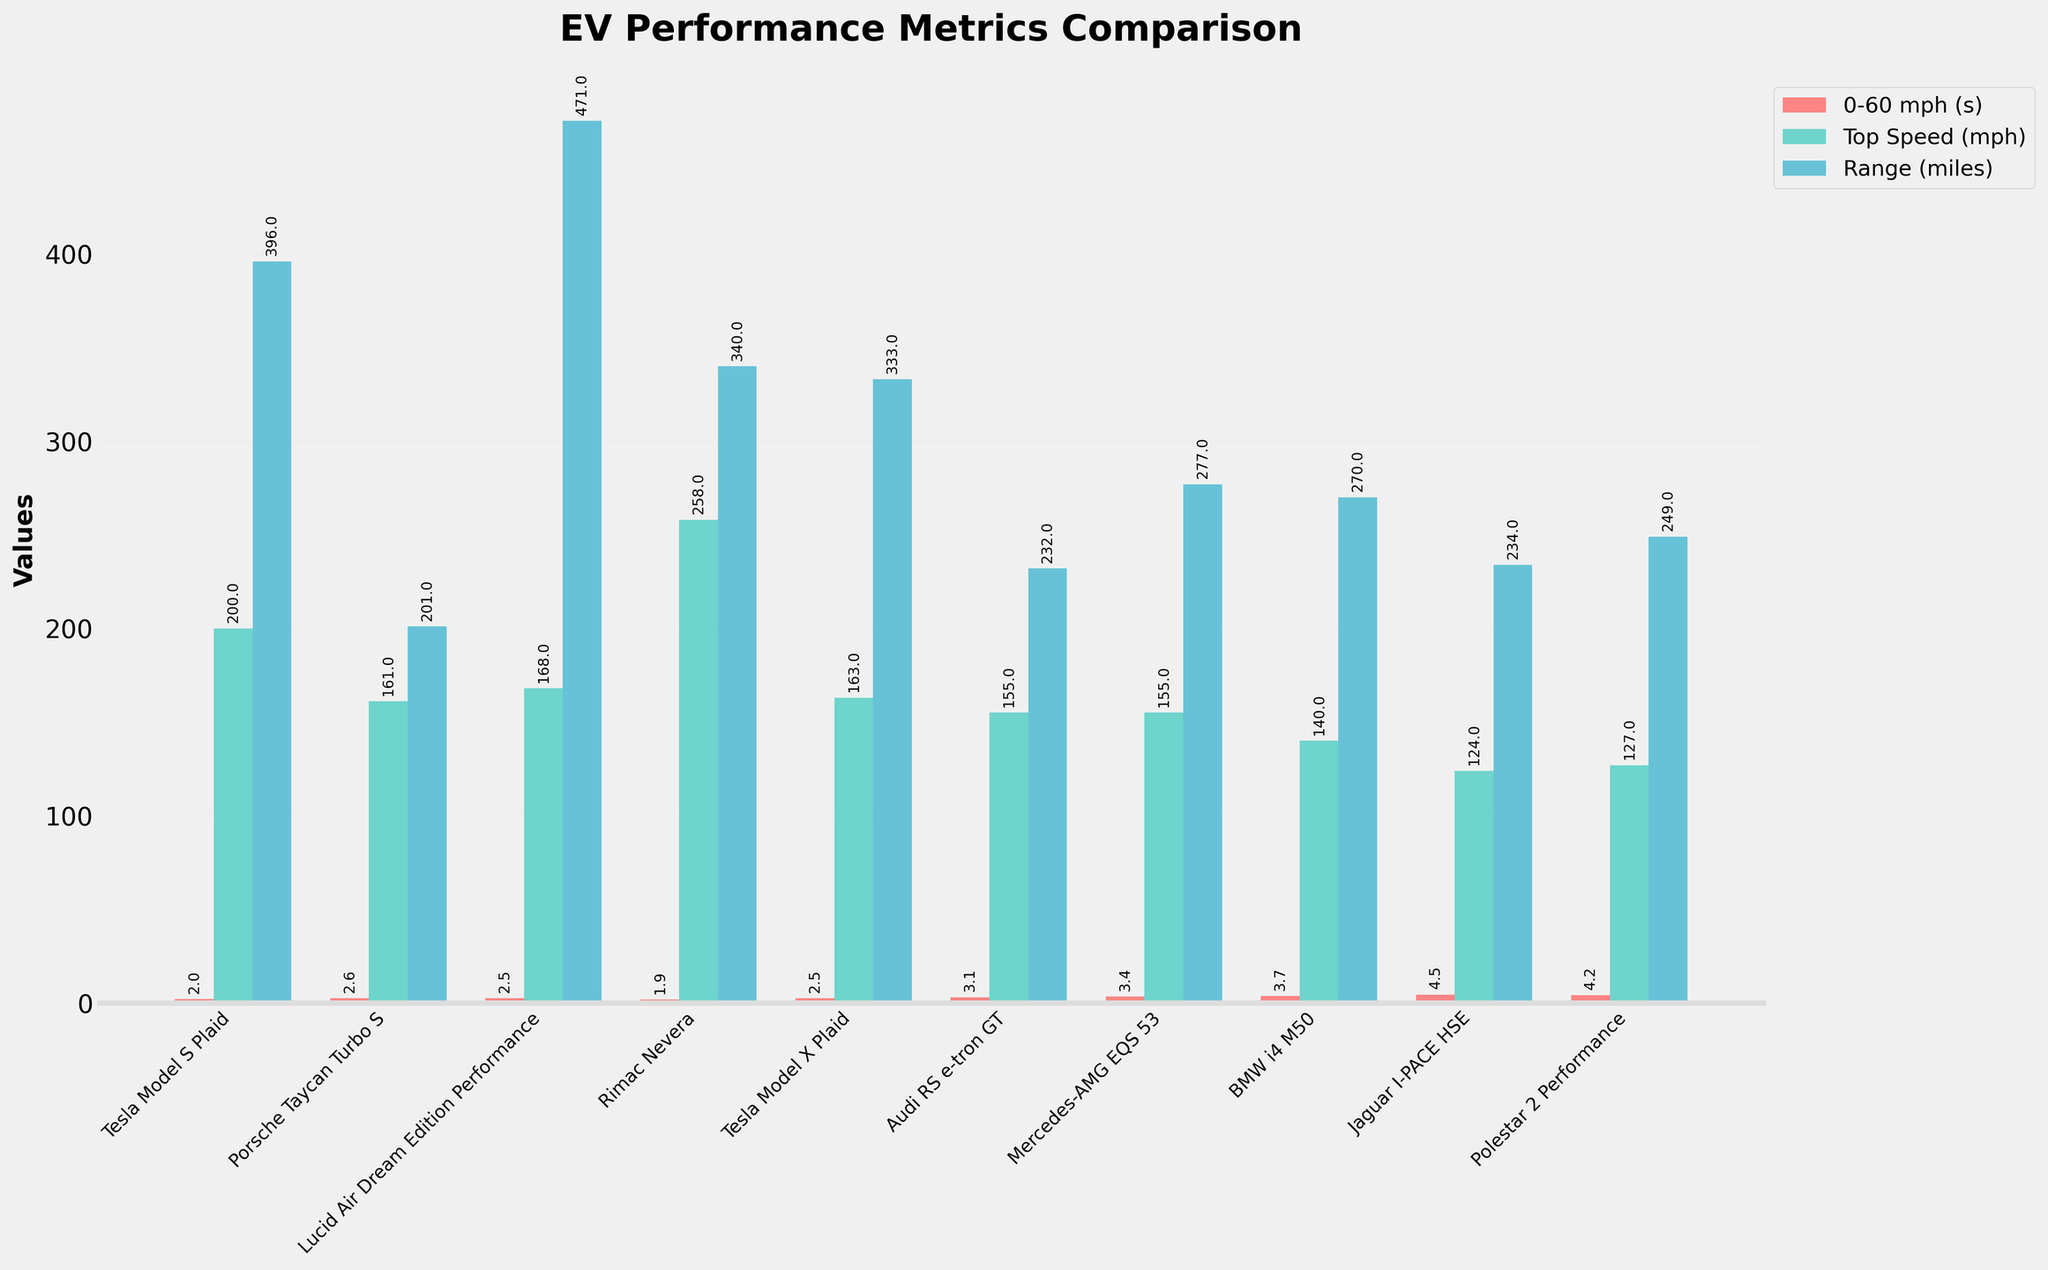Which model has the fastest 0-60 mph time? The fastest 0-60 mph time is represented by the shortest red bar. The Rimac Nevera has the shortest red bar, indicating it has the fastest 0-60 mph time.
Answer: Rimac Nevera Which model has the longest range? The longest range is represented by the tallest blue bar. The Lucid Air Dream Edition Performance has the tallest blue bar, indicating it has the longest range.
Answer: Lucid Air Dream Edition Performance Which two models have the exact same top speed? By looking at the height of the green bars, the Tesla Model X Plaid and the Porsche Taycan Turbo S both have green bars of the same height, indicating they have the same top speed.
Answer: Tesla Model X Plaid, Porsche Taycan Turbo S What's the difference in range between Tesla Model S Plaid and Audi RS e-tron GT? The range of Tesla Model S Plaid is 396 miles, and Audi RS e-tron GT is 232 miles. The difference is calculated by subtracting the smaller value from the larger one: 396 - 232 = 164 miles.
Answer: 164 miles Which model has the lowest top speed? The lowest top speed is represented by the shortest green bar. The Jaguar I-PACE HSE has the shortest green bar, indicating it has the lowest top speed.
Answer: Jaguar I-PACE HSE Which model has the second fastest 0-60 mph time, and what is it? The second fastest 0-60 mph time is represented by the second shortest red bar. The Tesla Model S Plaid has the second shortest red bar, indicating it has the second fastest 0-60 mph time at 1.99 seconds.
Answer: Tesla Model S Plaid, 1.99 seconds Which model combines both high top speed and long range and how is it visually represented? Visually, the model with both a tall green bar and a tall blue bar combines high top speed and long range. The Rimac Nevera stands out with high values in both green (258 mph) and blue (340 miles) bars.
Answer: Rimac Nevera What's the average top speed of the Tesla models? There are two Tesla models: Model S Plaid (200 mph) and Model X Plaid (163 mph). The average top speed is calculated by summing the two values and dividing by 2: (200 + 163) / 2 = 181.5 mph.
Answer: 181.5 mph 